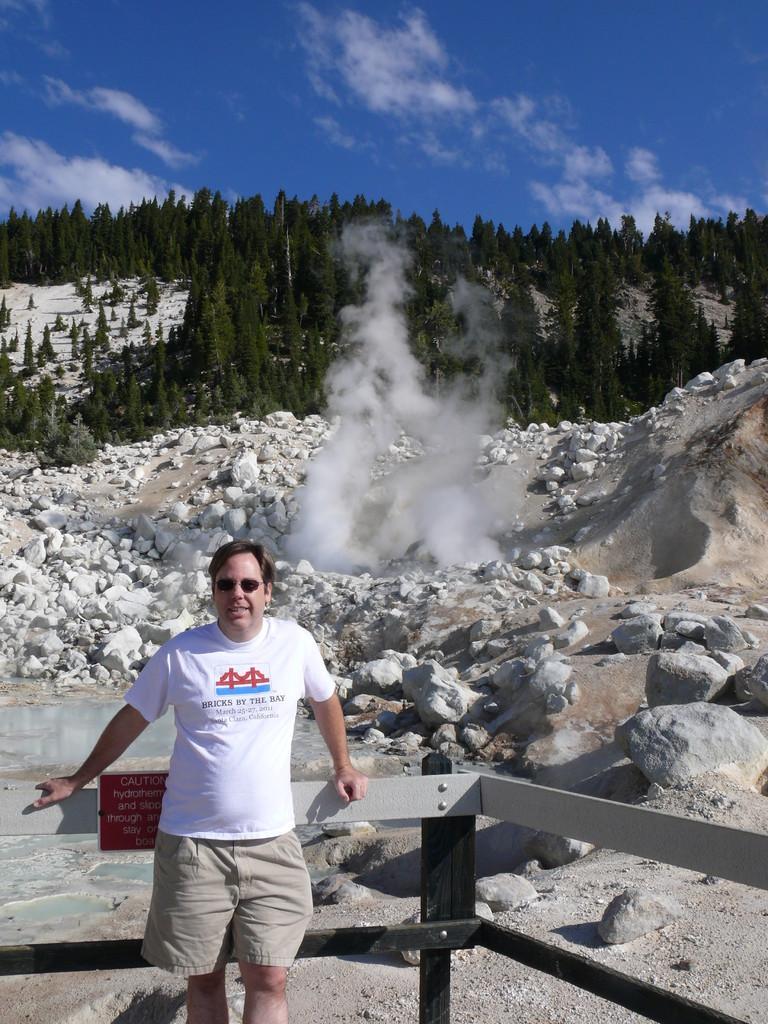In one or two sentences, can you explain what this image depicts? In this image I can see a man is standing in the front, I can see he is wearing white colour t shirt, shorts and black shades. Behind him I can see a red colour board and on it I can see something is written. In the background I can see number of trees, stones, smoke, clouds and the sky. 